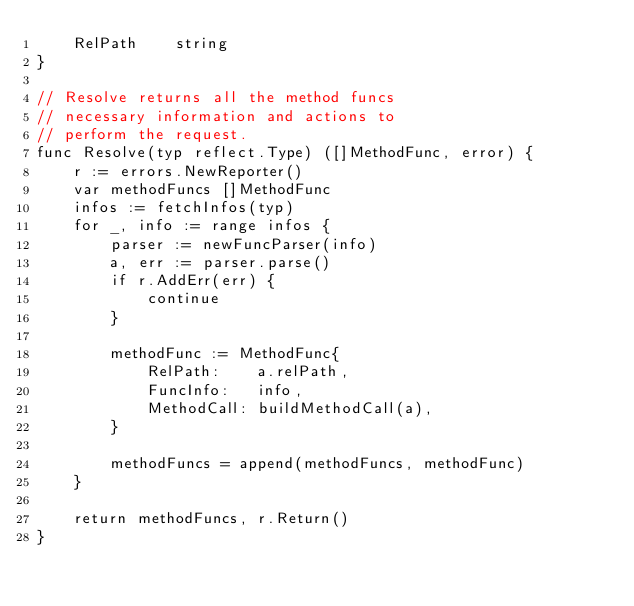Convert code to text. <code><loc_0><loc_0><loc_500><loc_500><_Go_>	RelPath    string
}

// Resolve returns all the method funcs
// necessary information and actions to
// perform the request.
func Resolve(typ reflect.Type) ([]MethodFunc, error) {
	r := errors.NewReporter()
	var methodFuncs []MethodFunc
	infos := fetchInfos(typ)
	for _, info := range infos {
		parser := newFuncParser(info)
		a, err := parser.parse()
		if r.AddErr(err) {
			continue
		}

		methodFunc := MethodFunc{
			RelPath:    a.relPath,
			FuncInfo:   info,
			MethodCall: buildMethodCall(a),
		}

		methodFuncs = append(methodFuncs, methodFunc)
	}

	return methodFuncs, r.Return()
}
</code> 